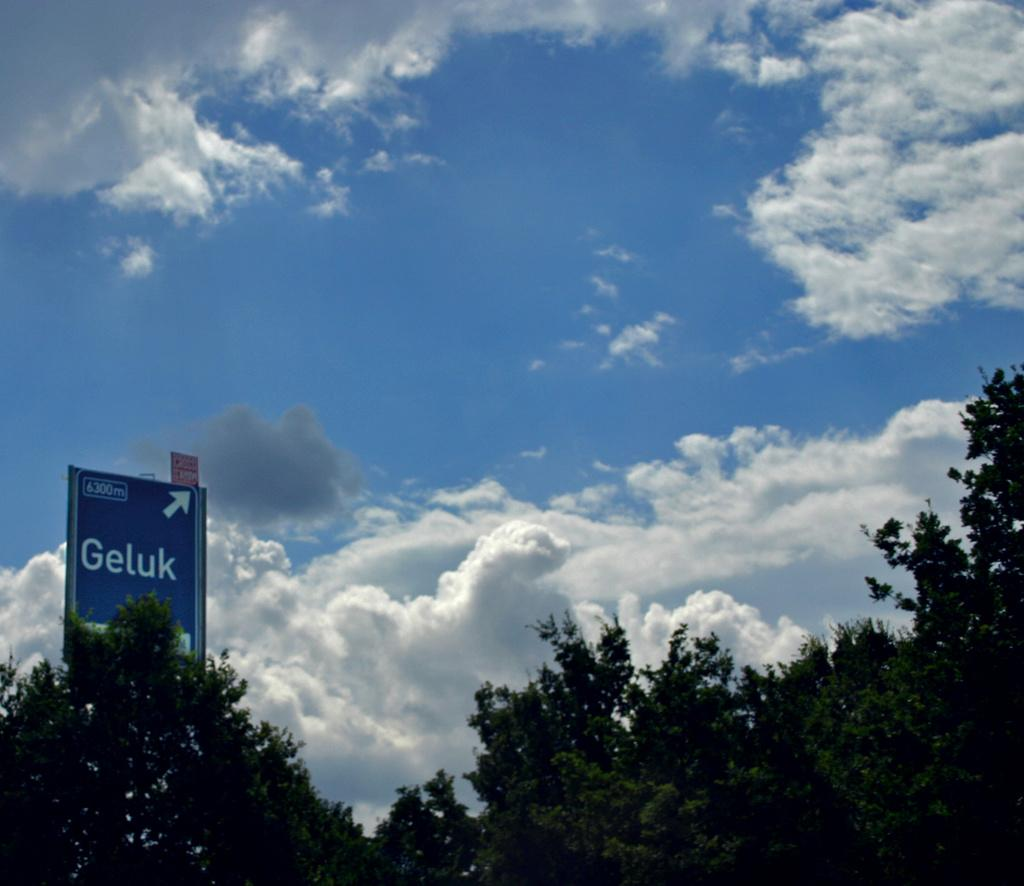What is located at the bottom of the picture? There are trees and a hoarding at the bottom of the picture. What is the weather like in the image? The sky is sunny, indicating a clear and bright day. Can you see any docks near the trees in the image? There is no dock present in the image; it features trees and a hoarding at the bottom of the picture. What type of bird can be seen perched on the hoarding in the image? There are no birds visible in the image, including wrens. 